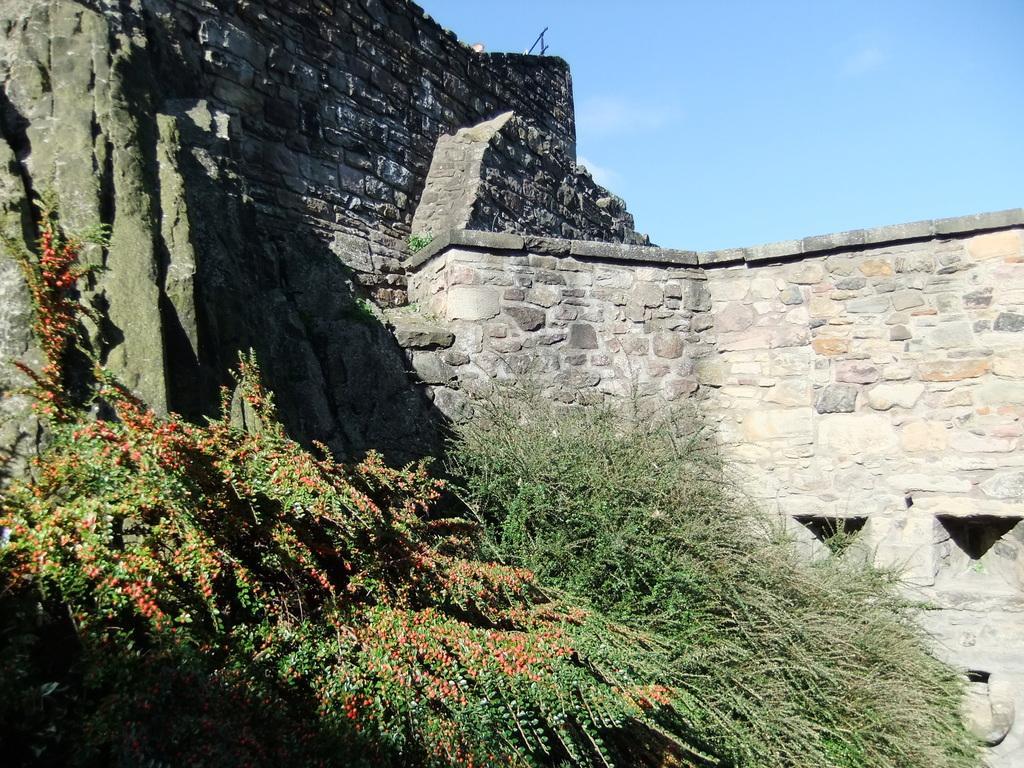Could you give a brief overview of what you see in this image? In this image, we can see the wall and some plants. We can also see the sky. 